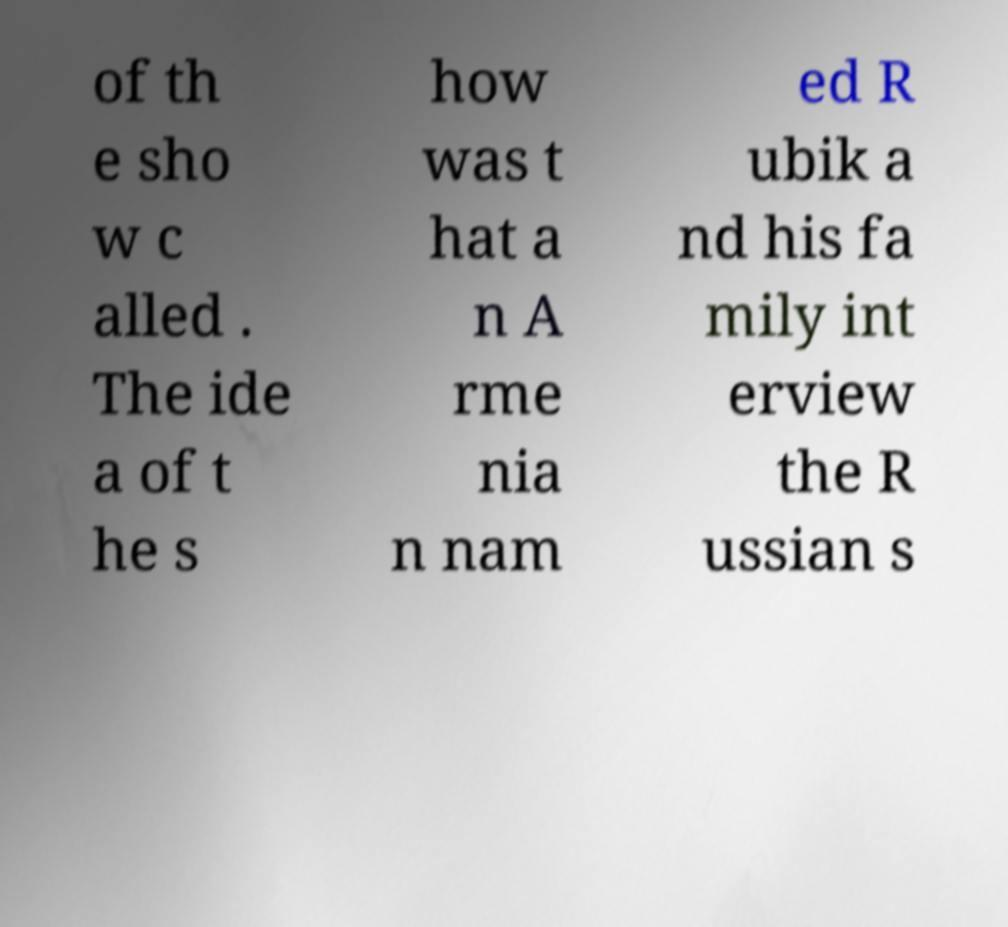Could you extract and type out the text from this image? of th e sho w c alled . The ide a of t he s how was t hat a n A rme nia n nam ed R ubik a nd his fa mily int erview the R ussian s 